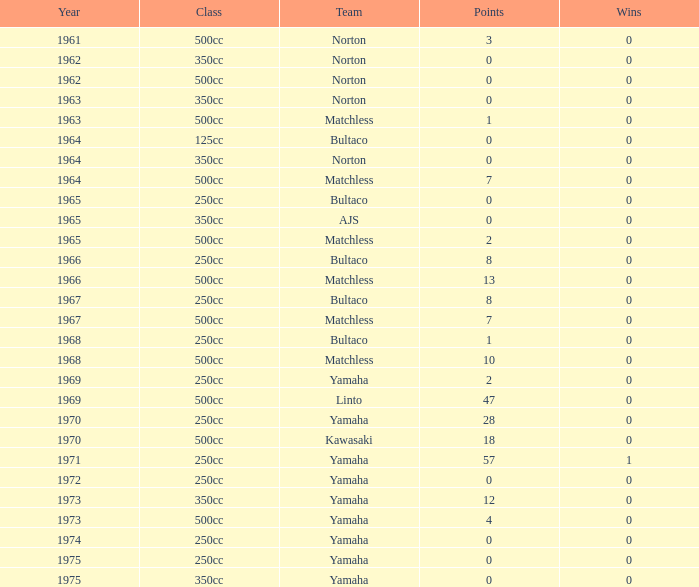What is the average wins in 250cc class for Bultaco with 8 points later than 1966? 0.0. 